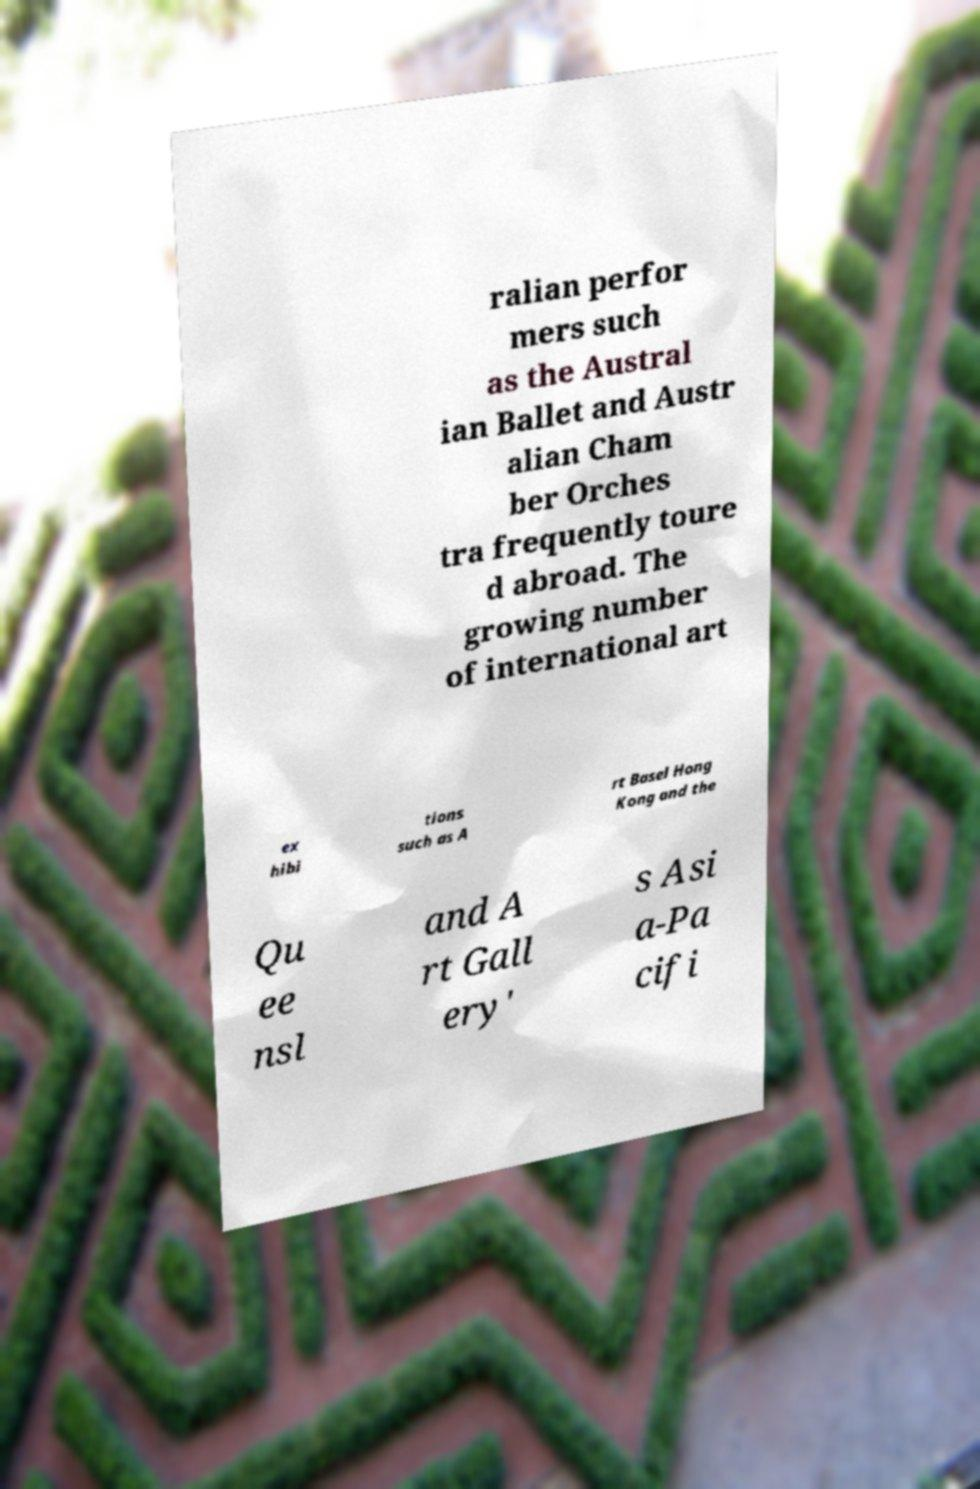What messages or text are displayed in this image? I need them in a readable, typed format. ralian perfor mers such as the Austral ian Ballet and Austr alian Cham ber Orches tra frequently toure d abroad. The growing number of international art ex hibi tions such as A rt Basel Hong Kong and the Qu ee nsl and A rt Gall ery' s Asi a-Pa cifi 